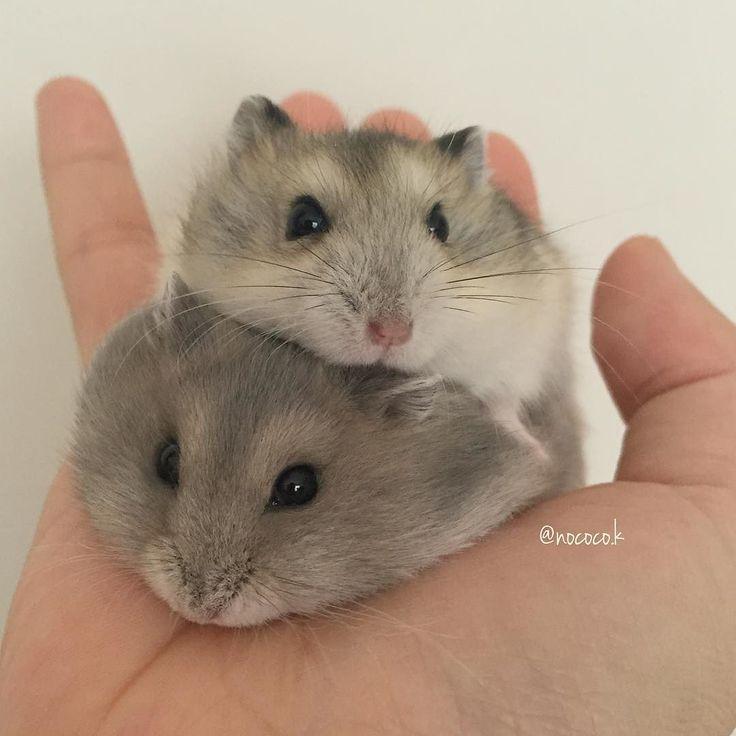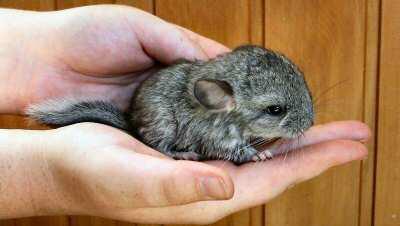The first image is the image on the left, the second image is the image on the right. Analyze the images presented: Is the assertion "One of the images clearly shows a hamster's tongue licking someone's finger." valid? Answer yes or no. No. 